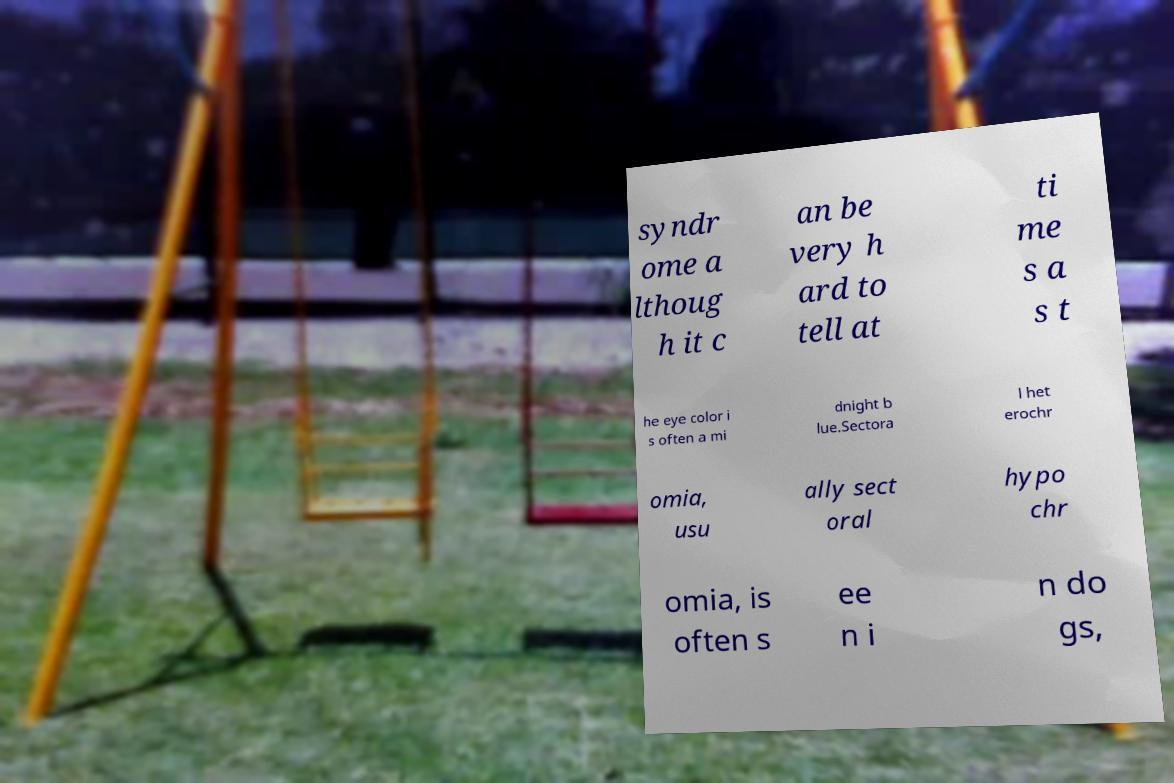I need the written content from this picture converted into text. Can you do that? syndr ome a lthoug h it c an be very h ard to tell at ti me s a s t he eye color i s often a mi dnight b lue.Sectora l het erochr omia, usu ally sect oral hypo chr omia, is often s ee n i n do gs, 